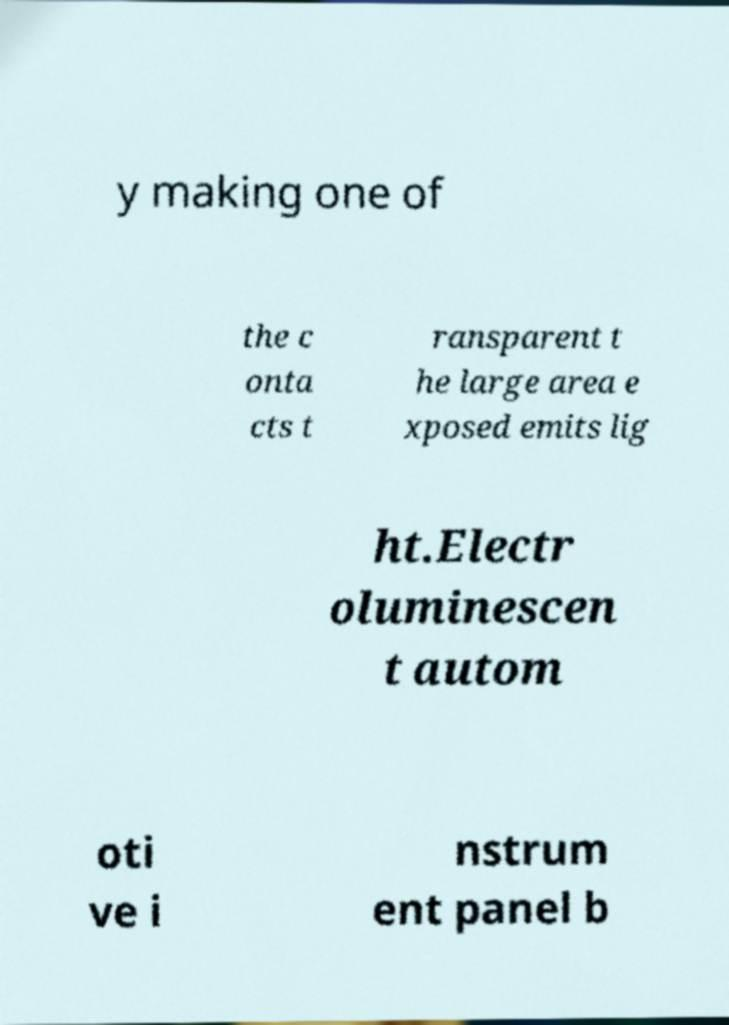Please identify and transcribe the text found in this image. y making one of the c onta cts t ransparent t he large area e xposed emits lig ht.Electr oluminescen t autom oti ve i nstrum ent panel b 